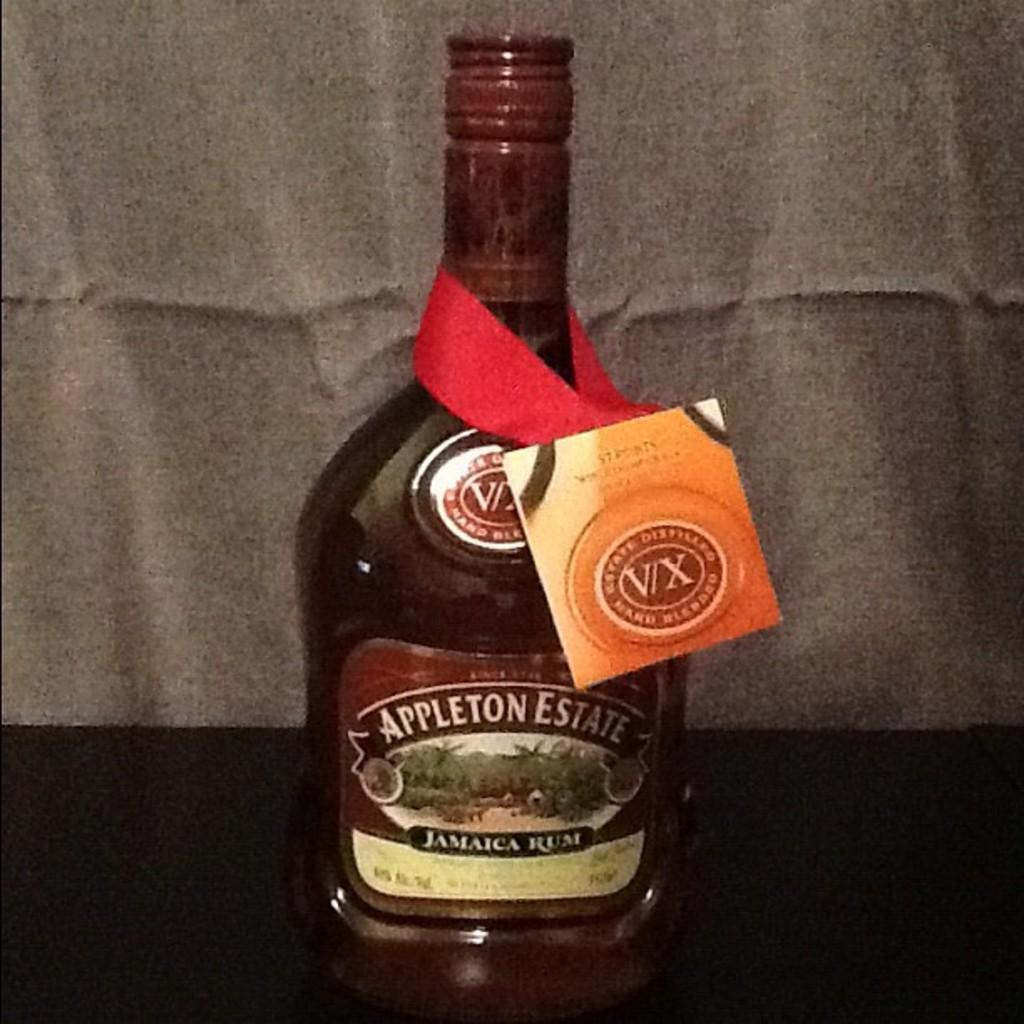Provide a one-sentence caption for the provided image. A bottle of Jamaican rum from Appleton Estates. 